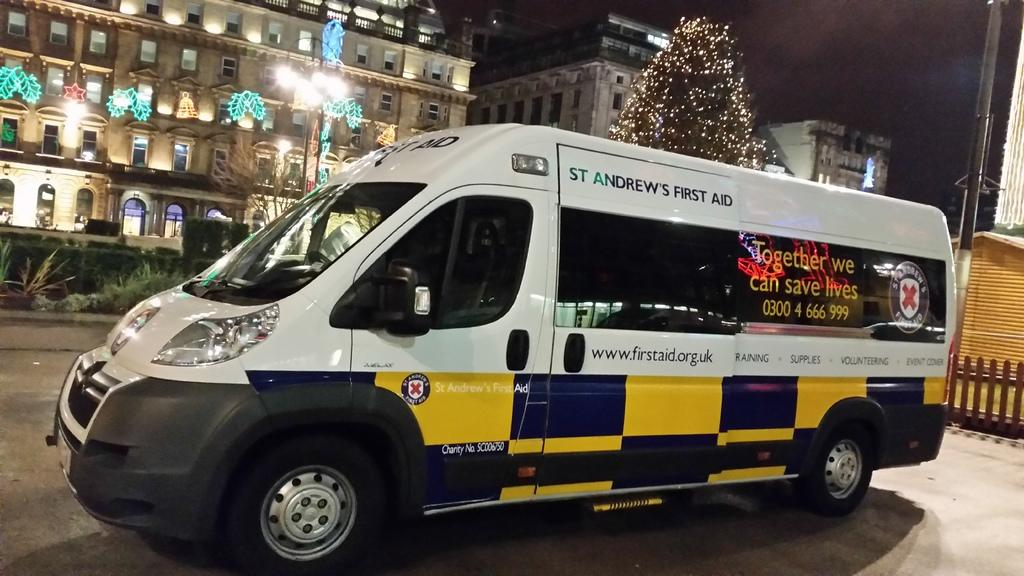<image>
Present a compact description of the photo's key features. White van which says "St. Andrews First Aid" on the side. 